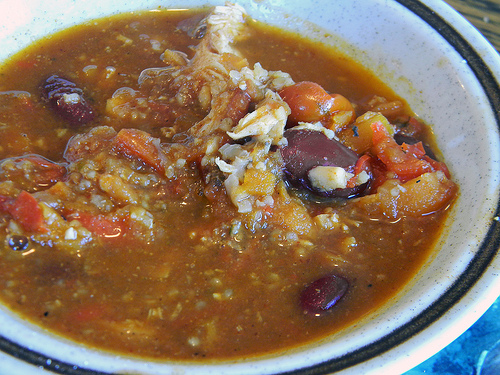<image>
Is there a beans in the bowl? Yes. The beans is contained within or inside the bowl, showing a containment relationship. 